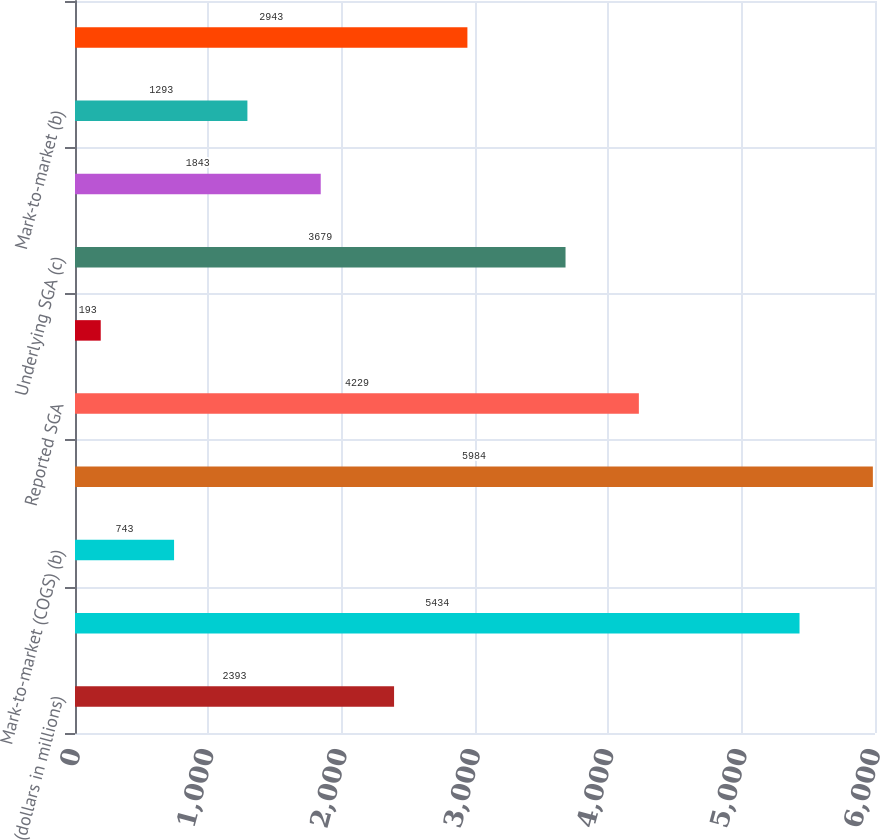Convert chart to OTSL. <chart><loc_0><loc_0><loc_500><loc_500><bar_chart><fcel>(dollars in millions)<fcel>Reported gross profit (a)<fcel>Mark-to-market (COGS) (b)<fcel>Underlying gross profit (c)<fcel>Reported SGA<fcel>Mark-to-market (SGA) (b)<fcel>Underlying SGA (c)<fcel>Reported operating profit<fcel>Mark-to-market (b)<fcel>Underlying operating profit<nl><fcel>2393<fcel>5434<fcel>743<fcel>5984<fcel>4229<fcel>193<fcel>3679<fcel>1843<fcel>1293<fcel>2943<nl></chart> 